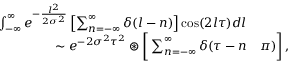<formula> <loc_0><loc_0><loc_500><loc_500>\begin{array} { r l } { \int _ { - \infty } ^ { \infty } e ^ { - \frac { l ^ { 2 } } { 2 \sigma ^ { 2 } } } \left [ \sum _ { n = - \infty } ^ { \infty } \delta ( l - n ) \right ] \cos ( 2 l \tau ) d l } \\ { \sim e ^ { - 2 \sigma ^ { 2 } \tau ^ { 2 } } \circledast \left [ \sum _ { n = - \infty } ^ { \infty } \delta ( \tau - n } & \pi ) \right ] \, , } \end{array}</formula> 